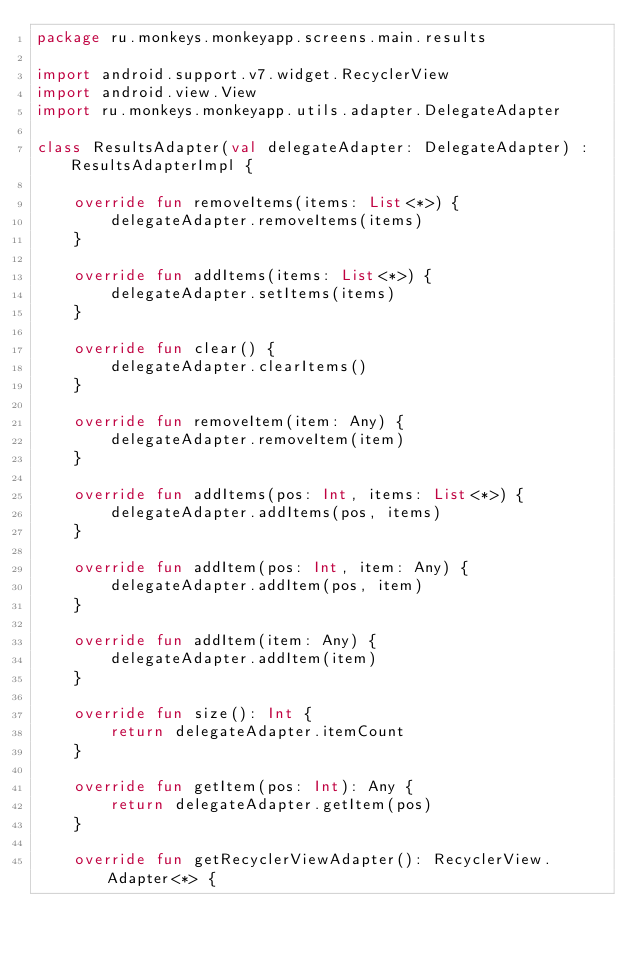Convert code to text. <code><loc_0><loc_0><loc_500><loc_500><_Kotlin_>package ru.monkeys.monkeyapp.screens.main.results

import android.support.v7.widget.RecyclerView
import android.view.View
import ru.monkeys.monkeyapp.utils.adapter.DelegateAdapter

class ResultsAdapter(val delegateAdapter: DelegateAdapter) : ResultsAdapterImpl {

    override fun removeItems(items: List<*>) {
        delegateAdapter.removeItems(items)
    }

    override fun addItems(items: List<*>) {
        delegateAdapter.setItems(items)
    }

    override fun clear() {
        delegateAdapter.clearItems()
    }

    override fun removeItem(item: Any) {
        delegateAdapter.removeItem(item)
    }

    override fun addItems(pos: Int, items: List<*>) {
        delegateAdapter.addItems(pos, items)
    }

    override fun addItem(pos: Int, item: Any) {
        delegateAdapter.addItem(pos, item)
    }

    override fun addItem(item: Any) {
        delegateAdapter.addItem(item)
    }

    override fun size(): Int {
        return delegateAdapter.itemCount
    }

    override fun getItem(pos: Int): Any {
        return delegateAdapter.getItem(pos)
    }

    override fun getRecyclerViewAdapter(): RecyclerView.Adapter<*> {</code> 